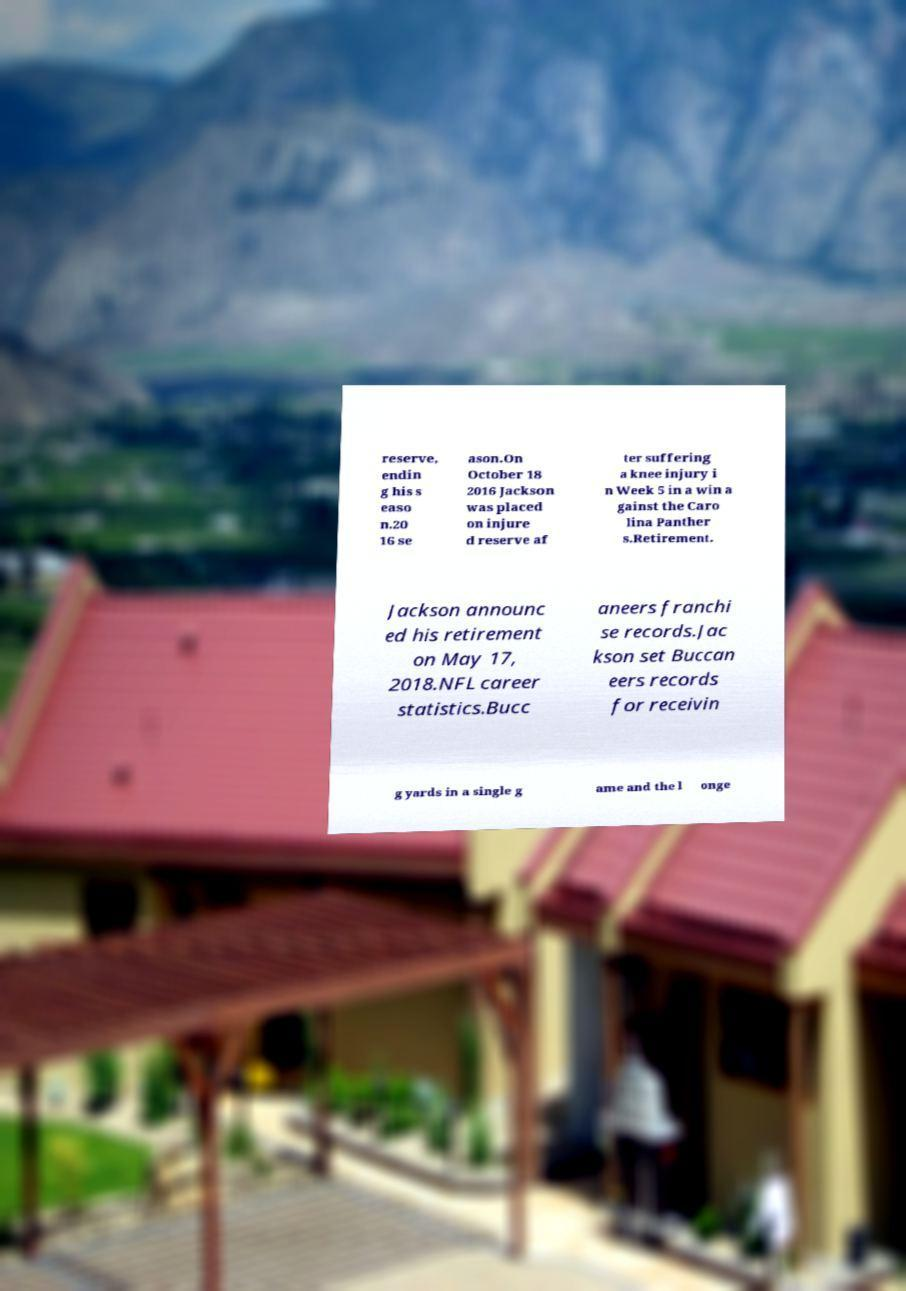Could you extract and type out the text from this image? reserve, endin g his s easo n.20 16 se ason.On October 18 2016 Jackson was placed on injure d reserve af ter suffering a knee injury i n Week 5 in a win a gainst the Caro lina Panther s.Retirement. Jackson announc ed his retirement on May 17, 2018.NFL career statistics.Bucc aneers franchi se records.Jac kson set Buccan eers records for receivin g yards in a single g ame and the l onge 